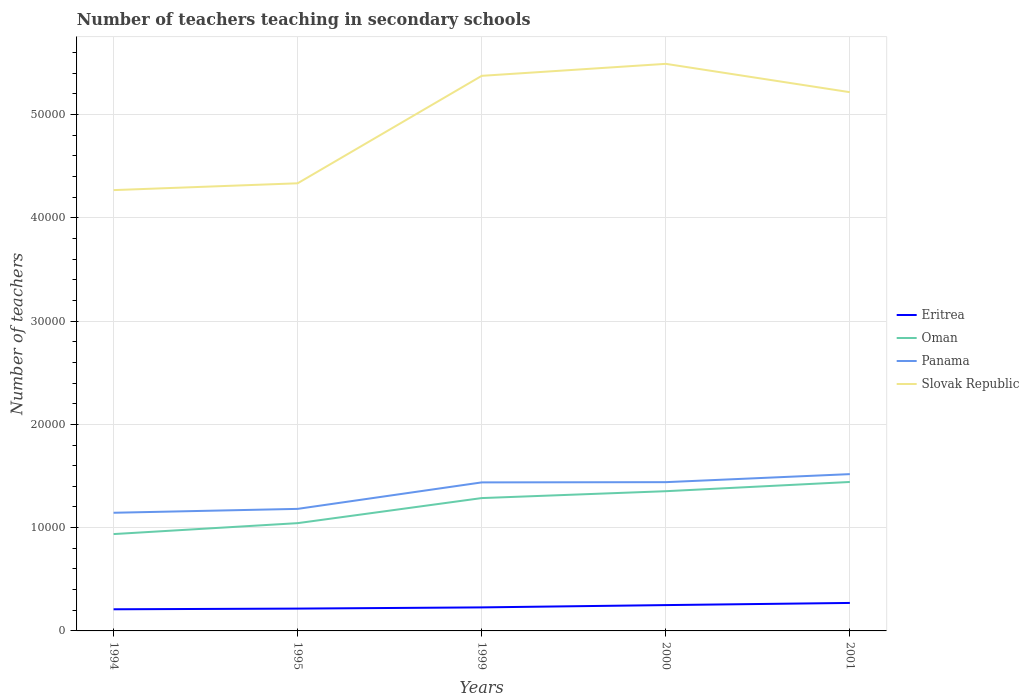Does the line corresponding to Eritrea intersect with the line corresponding to Panama?
Make the answer very short. No. Is the number of lines equal to the number of legend labels?
Offer a terse response. Yes. Across all years, what is the maximum number of teachers teaching in secondary schools in Slovak Republic?
Your answer should be very brief. 4.27e+04. In which year was the number of teachers teaching in secondary schools in Eritrea maximum?
Provide a short and direct response. 1994. What is the total number of teachers teaching in secondary schools in Slovak Republic in the graph?
Give a very brief answer. -660. What is the difference between the highest and the second highest number of teachers teaching in secondary schools in Oman?
Offer a terse response. 5046. What is the difference between the highest and the lowest number of teachers teaching in secondary schools in Eritrea?
Offer a very short reply. 2. Are the values on the major ticks of Y-axis written in scientific E-notation?
Ensure brevity in your answer.  No. Does the graph contain any zero values?
Provide a succinct answer. No. What is the title of the graph?
Your answer should be compact. Number of teachers teaching in secondary schools. What is the label or title of the Y-axis?
Keep it short and to the point. Number of teachers. What is the Number of teachers in Eritrea in 1994?
Make the answer very short. 2095. What is the Number of teachers of Oman in 1994?
Give a very brief answer. 9376. What is the Number of teachers of Panama in 1994?
Make the answer very short. 1.14e+04. What is the Number of teachers of Slovak Republic in 1994?
Provide a short and direct response. 4.27e+04. What is the Number of teachers of Eritrea in 1995?
Your response must be concise. 2162. What is the Number of teachers in Oman in 1995?
Your response must be concise. 1.04e+04. What is the Number of teachers in Panama in 1995?
Your answer should be very brief. 1.18e+04. What is the Number of teachers in Slovak Republic in 1995?
Keep it short and to the point. 4.33e+04. What is the Number of teachers in Eritrea in 1999?
Keep it short and to the point. 2278. What is the Number of teachers of Oman in 1999?
Your answer should be very brief. 1.29e+04. What is the Number of teachers of Panama in 1999?
Your response must be concise. 1.44e+04. What is the Number of teachers of Slovak Republic in 1999?
Your answer should be compact. 5.37e+04. What is the Number of teachers in Eritrea in 2000?
Your response must be concise. 2501. What is the Number of teachers of Oman in 2000?
Give a very brief answer. 1.35e+04. What is the Number of teachers of Panama in 2000?
Offer a terse response. 1.44e+04. What is the Number of teachers of Slovak Republic in 2000?
Keep it short and to the point. 5.49e+04. What is the Number of teachers in Eritrea in 2001?
Your answer should be very brief. 2710. What is the Number of teachers in Oman in 2001?
Your response must be concise. 1.44e+04. What is the Number of teachers in Panama in 2001?
Provide a succinct answer. 1.52e+04. What is the Number of teachers of Slovak Republic in 2001?
Your answer should be compact. 5.22e+04. Across all years, what is the maximum Number of teachers in Eritrea?
Your response must be concise. 2710. Across all years, what is the maximum Number of teachers in Oman?
Your response must be concise. 1.44e+04. Across all years, what is the maximum Number of teachers in Panama?
Provide a short and direct response. 1.52e+04. Across all years, what is the maximum Number of teachers of Slovak Republic?
Your answer should be compact. 5.49e+04. Across all years, what is the minimum Number of teachers in Eritrea?
Your response must be concise. 2095. Across all years, what is the minimum Number of teachers of Oman?
Your answer should be compact. 9376. Across all years, what is the minimum Number of teachers in Panama?
Keep it short and to the point. 1.14e+04. Across all years, what is the minimum Number of teachers of Slovak Republic?
Your answer should be compact. 4.27e+04. What is the total Number of teachers in Eritrea in the graph?
Your answer should be very brief. 1.17e+04. What is the total Number of teachers of Oman in the graph?
Keep it short and to the point. 6.06e+04. What is the total Number of teachers of Panama in the graph?
Offer a terse response. 6.72e+04. What is the total Number of teachers of Slovak Republic in the graph?
Make the answer very short. 2.47e+05. What is the difference between the Number of teachers of Eritrea in 1994 and that in 1995?
Make the answer very short. -67. What is the difference between the Number of teachers of Oman in 1994 and that in 1995?
Provide a succinct answer. -1059. What is the difference between the Number of teachers of Panama in 1994 and that in 1995?
Your answer should be compact. -377. What is the difference between the Number of teachers in Slovak Republic in 1994 and that in 1995?
Provide a succinct answer. -660. What is the difference between the Number of teachers of Eritrea in 1994 and that in 1999?
Keep it short and to the point. -183. What is the difference between the Number of teachers in Oman in 1994 and that in 1999?
Your response must be concise. -3486. What is the difference between the Number of teachers of Panama in 1994 and that in 1999?
Your answer should be compact. -2940. What is the difference between the Number of teachers in Slovak Republic in 1994 and that in 1999?
Make the answer very short. -1.11e+04. What is the difference between the Number of teachers in Eritrea in 1994 and that in 2000?
Provide a short and direct response. -406. What is the difference between the Number of teachers in Oman in 1994 and that in 2000?
Your response must be concise. -4152. What is the difference between the Number of teachers of Panama in 1994 and that in 2000?
Provide a succinct answer. -2964. What is the difference between the Number of teachers in Slovak Republic in 1994 and that in 2000?
Provide a succinct answer. -1.22e+04. What is the difference between the Number of teachers of Eritrea in 1994 and that in 2001?
Provide a short and direct response. -615. What is the difference between the Number of teachers in Oman in 1994 and that in 2001?
Provide a short and direct response. -5046. What is the difference between the Number of teachers in Panama in 1994 and that in 2001?
Provide a short and direct response. -3741. What is the difference between the Number of teachers in Slovak Republic in 1994 and that in 2001?
Provide a succinct answer. -9480. What is the difference between the Number of teachers in Eritrea in 1995 and that in 1999?
Make the answer very short. -116. What is the difference between the Number of teachers of Oman in 1995 and that in 1999?
Your response must be concise. -2427. What is the difference between the Number of teachers of Panama in 1995 and that in 1999?
Your answer should be compact. -2563. What is the difference between the Number of teachers in Slovak Republic in 1995 and that in 1999?
Provide a succinct answer. -1.04e+04. What is the difference between the Number of teachers of Eritrea in 1995 and that in 2000?
Make the answer very short. -339. What is the difference between the Number of teachers of Oman in 1995 and that in 2000?
Offer a very short reply. -3093. What is the difference between the Number of teachers of Panama in 1995 and that in 2000?
Your response must be concise. -2587. What is the difference between the Number of teachers in Slovak Republic in 1995 and that in 2000?
Ensure brevity in your answer.  -1.16e+04. What is the difference between the Number of teachers of Eritrea in 1995 and that in 2001?
Your answer should be compact. -548. What is the difference between the Number of teachers in Oman in 1995 and that in 2001?
Your answer should be compact. -3987. What is the difference between the Number of teachers of Panama in 1995 and that in 2001?
Offer a very short reply. -3364. What is the difference between the Number of teachers of Slovak Republic in 1995 and that in 2001?
Your answer should be compact. -8820. What is the difference between the Number of teachers of Eritrea in 1999 and that in 2000?
Ensure brevity in your answer.  -223. What is the difference between the Number of teachers of Oman in 1999 and that in 2000?
Make the answer very short. -666. What is the difference between the Number of teachers of Panama in 1999 and that in 2000?
Your answer should be very brief. -24. What is the difference between the Number of teachers in Slovak Republic in 1999 and that in 2000?
Offer a very short reply. -1160. What is the difference between the Number of teachers in Eritrea in 1999 and that in 2001?
Your answer should be very brief. -432. What is the difference between the Number of teachers in Oman in 1999 and that in 2001?
Give a very brief answer. -1560. What is the difference between the Number of teachers of Panama in 1999 and that in 2001?
Your answer should be compact. -801. What is the difference between the Number of teachers of Slovak Republic in 1999 and that in 2001?
Keep it short and to the point. 1585. What is the difference between the Number of teachers in Eritrea in 2000 and that in 2001?
Make the answer very short. -209. What is the difference between the Number of teachers in Oman in 2000 and that in 2001?
Make the answer very short. -894. What is the difference between the Number of teachers of Panama in 2000 and that in 2001?
Your answer should be compact. -777. What is the difference between the Number of teachers of Slovak Republic in 2000 and that in 2001?
Your answer should be very brief. 2745. What is the difference between the Number of teachers of Eritrea in 1994 and the Number of teachers of Oman in 1995?
Give a very brief answer. -8340. What is the difference between the Number of teachers of Eritrea in 1994 and the Number of teachers of Panama in 1995?
Ensure brevity in your answer.  -9722. What is the difference between the Number of teachers in Eritrea in 1994 and the Number of teachers in Slovak Republic in 1995?
Your answer should be compact. -4.12e+04. What is the difference between the Number of teachers in Oman in 1994 and the Number of teachers in Panama in 1995?
Your response must be concise. -2441. What is the difference between the Number of teachers in Oman in 1994 and the Number of teachers in Slovak Republic in 1995?
Give a very brief answer. -3.40e+04. What is the difference between the Number of teachers in Panama in 1994 and the Number of teachers in Slovak Republic in 1995?
Offer a terse response. -3.19e+04. What is the difference between the Number of teachers in Eritrea in 1994 and the Number of teachers in Oman in 1999?
Provide a short and direct response. -1.08e+04. What is the difference between the Number of teachers in Eritrea in 1994 and the Number of teachers in Panama in 1999?
Your answer should be compact. -1.23e+04. What is the difference between the Number of teachers in Eritrea in 1994 and the Number of teachers in Slovak Republic in 1999?
Ensure brevity in your answer.  -5.16e+04. What is the difference between the Number of teachers of Oman in 1994 and the Number of teachers of Panama in 1999?
Provide a short and direct response. -5004. What is the difference between the Number of teachers in Oman in 1994 and the Number of teachers in Slovak Republic in 1999?
Offer a very short reply. -4.44e+04. What is the difference between the Number of teachers in Panama in 1994 and the Number of teachers in Slovak Republic in 1999?
Make the answer very short. -4.23e+04. What is the difference between the Number of teachers in Eritrea in 1994 and the Number of teachers in Oman in 2000?
Provide a short and direct response. -1.14e+04. What is the difference between the Number of teachers of Eritrea in 1994 and the Number of teachers of Panama in 2000?
Offer a very short reply. -1.23e+04. What is the difference between the Number of teachers of Eritrea in 1994 and the Number of teachers of Slovak Republic in 2000?
Keep it short and to the point. -5.28e+04. What is the difference between the Number of teachers of Oman in 1994 and the Number of teachers of Panama in 2000?
Provide a short and direct response. -5028. What is the difference between the Number of teachers in Oman in 1994 and the Number of teachers in Slovak Republic in 2000?
Offer a very short reply. -4.55e+04. What is the difference between the Number of teachers of Panama in 1994 and the Number of teachers of Slovak Republic in 2000?
Ensure brevity in your answer.  -4.35e+04. What is the difference between the Number of teachers of Eritrea in 1994 and the Number of teachers of Oman in 2001?
Provide a short and direct response. -1.23e+04. What is the difference between the Number of teachers of Eritrea in 1994 and the Number of teachers of Panama in 2001?
Ensure brevity in your answer.  -1.31e+04. What is the difference between the Number of teachers of Eritrea in 1994 and the Number of teachers of Slovak Republic in 2001?
Make the answer very short. -5.01e+04. What is the difference between the Number of teachers of Oman in 1994 and the Number of teachers of Panama in 2001?
Your response must be concise. -5805. What is the difference between the Number of teachers in Oman in 1994 and the Number of teachers in Slovak Republic in 2001?
Provide a succinct answer. -4.28e+04. What is the difference between the Number of teachers in Panama in 1994 and the Number of teachers in Slovak Republic in 2001?
Make the answer very short. -4.07e+04. What is the difference between the Number of teachers of Eritrea in 1995 and the Number of teachers of Oman in 1999?
Provide a short and direct response. -1.07e+04. What is the difference between the Number of teachers in Eritrea in 1995 and the Number of teachers in Panama in 1999?
Offer a terse response. -1.22e+04. What is the difference between the Number of teachers of Eritrea in 1995 and the Number of teachers of Slovak Republic in 1999?
Make the answer very short. -5.16e+04. What is the difference between the Number of teachers of Oman in 1995 and the Number of teachers of Panama in 1999?
Keep it short and to the point. -3945. What is the difference between the Number of teachers in Oman in 1995 and the Number of teachers in Slovak Republic in 1999?
Provide a short and direct response. -4.33e+04. What is the difference between the Number of teachers of Panama in 1995 and the Number of teachers of Slovak Republic in 1999?
Your answer should be compact. -4.19e+04. What is the difference between the Number of teachers in Eritrea in 1995 and the Number of teachers in Oman in 2000?
Offer a terse response. -1.14e+04. What is the difference between the Number of teachers in Eritrea in 1995 and the Number of teachers in Panama in 2000?
Ensure brevity in your answer.  -1.22e+04. What is the difference between the Number of teachers in Eritrea in 1995 and the Number of teachers in Slovak Republic in 2000?
Offer a very short reply. -5.27e+04. What is the difference between the Number of teachers in Oman in 1995 and the Number of teachers in Panama in 2000?
Offer a very short reply. -3969. What is the difference between the Number of teachers of Oman in 1995 and the Number of teachers of Slovak Republic in 2000?
Offer a terse response. -4.45e+04. What is the difference between the Number of teachers of Panama in 1995 and the Number of teachers of Slovak Republic in 2000?
Your response must be concise. -4.31e+04. What is the difference between the Number of teachers of Eritrea in 1995 and the Number of teachers of Oman in 2001?
Provide a short and direct response. -1.23e+04. What is the difference between the Number of teachers in Eritrea in 1995 and the Number of teachers in Panama in 2001?
Offer a very short reply. -1.30e+04. What is the difference between the Number of teachers in Eritrea in 1995 and the Number of teachers in Slovak Republic in 2001?
Offer a very short reply. -5.00e+04. What is the difference between the Number of teachers of Oman in 1995 and the Number of teachers of Panama in 2001?
Offer a terse response. -4746. What is the difference between the Number of teachers of Oman in 1995 and the Number of teachers of Slovak Republic in 2001?
Your answer should be very brief. -4.17e+04. What is the difference between the Number of teachers of Panama in 1995 and the Number of teachers of Slovak Republic in 2001?
Your response must be concise. -4.03e+04. What is the difference between the Number of teachers in Eritrea in 1999 and the Number of teachers in Oman in 2000?
Your response must be concise. -1.12e+04. What is the difference between the Number of teachers of Eritrea in 1999 and the Number of teachers of Panama in 2000?
Offer a terse response. -1.21e+04. What is the difference between the Number of teachers of Eritrea in 1999 and the Number of teachers of Slovak Republic in 2000?
Offer a terse response. -5.26e+04. What is the difference between the Number of teachers in Oman in 1999 and the Number of teachers in Panama in 2000?
Offer a terse response. -1542. What is the difference between the Number of teachers in Oman in 1999 and the Number of teachers in Slovak Republic in 2000?
Keep it short and to the point. -4.20e+04. What is the difference between the Number of teachers in Panama in 1999 and the Number of teachers in Slovak Republic in 2000?
Offer a terse response. -4.05e+04. What is the difference between the Number of teachers in Eritrea in 1999 and the Number of teachers in Oman in 2001?
Provide a short and direct response. -1.21e+04. What is the difference between the Number of teachers in Eritrea in 1999 and the Number of teachers in Panama in 2001?
Give a very brief answer. -1.29e+04. What is the difference between the Number of teachers of Eritrea in 1999 and the Number of teachers of Slovak Republic in 2001?
Your answer should be compact. -4.99e+04. What is the difference between the Number of teachers of Oman in 1999 and the Number of teachers of Panama in 2001?
Your answer should be very brief. -2319. What is the difference between the Number of teachers in Oman in 1999 and the Number of teachers in Slovak Republic in 2001?
Ensure brevity in your answer.  -3.93e+04. What is the difference between the Number of teachers of Panama in 1999 and the Number of teachers of Slovak Republic in 2001?
Offer a very short reply. -3.78e+04. What is the difference between the Number of teachers in Eritrea in 2000 and the Number of teachers in Oman in 2001?
Your answer should be very brief. -1.19e+04. What is the difference between the Number of teachers in Eritrea in 2000 and the Number of teachers in Panama in 2001?
Offer a very short reply. -1.27e+04. What is the difference between the Number of teachers of Eritrea in 2000 and the Number of teachers of Slovak Republic in 2001?
Give a very brief answer. -4.97e+04. What is the difference between the Number of teachers of Oman in 2000 and the Number of teachers of Panama in 2001?
Provide a short and direct response. -1653. What is the difference between the Number of teachers in Oman in 2000 and the Number of teachers in Slovak Republic in 2001?
Keep it short and to the point. -3.86e+04. What is the difference between the Number of teachers in Panama in 2000 and the Number of teachers in Slovak Republic in 2001?
Your answer should be very brief. -3.78e+04. What is the average Number of teachers of Eritrea per year?
Your answer should be very brief. 2349.2. What is the average Number of teachers of Oman per year?
Keep it short and to the point. 1.21e+04. What is the average Number of teachers of Panama per year?
Provide a short and direct response. 1.34e+04. What is the average Number of teachers of Slovak Republic per year?
Offer a terse response. 4.94e+04. In the year 1994, what is the difference between the Number of teachers of Eritrea and Number of teachers of Oman?
Offer a terse response. -7281. In the year 1994, what is the difference between the Number of teachers in Eritrea and Number of teachers in Panama?
Ensure brevity in your answer.  -9345. In the year 1994, what is the difference between the Number of teachers in Eritrea and Number of teachers in Slovak Republic?
Your answer should be very brief. -4.06e+04. In the year 1994, what is the difference between the Number of teachers in Oman and Number of teachers in Panama?
Offer a very short reply. -2064. In the year 1994, what is the difference between the Number of teachers of Oman and Number of teachers of Slovak Republic?
Provide a succinct answer. -3.33e+04. In the year 1994, what is the difference between the Number of teachers in Panama and Number of teachers in Slovak Republic?
Your answer should be compact. -3.12e+04. In the year 1995, what is the difference between the Number of teachers in Eritrea and Number of teachers in Oman?
Offer a very short reply. -8273. In the year 1995, what is the difference between the Number of teachers of Eritrea and Number of teachers of Panama?
Make the answer very short. -9655. In the year 1995, what is the difference between the Number of teachers of Eritrea and Number of teachers of Slovak Republic?
Ensure brevity in your answer.  -4.12e+04. In the year 1995, what is the difference between the Number of teachers in Oman and Number of teachers in Panama?
Your answer should be compact. -1382. In the year 1995, what is the difference between the Number of teachers of Oman and Number of teachers of Slovak Republic?
Offer a very short reply. -3.29e+04. In the year 1995, what is the difference between the Number of teachers in Panama and Number of teachers in Slovak Republic?
Provide a succinct answer. -3.15e+04. In the year 1999, what is the difference between the Number of teachers in Eritrea and Number of teachers in Oman?
Keep it short and to the point. -1.06e+04. In the year 1999, what is the difference between the Number of teachers in Eritrea and Number of teachers in Panama?
Offer a terse response. -1.21e+04. In the year 1999, what is the difference between the Number of teachers of Eritrea and Number of teachers of Slovak Republic?
Your answer should be compact. -5.15e+04. In the year 1999, what is the difference between the Number of teachers of Oman and Number of teachers of Panama?
Make the answer very short. -1518. In the year 1999, what is the difference between the Number of teachers of Oman and Number of teachers of Slovak Republic?
Your answer should be compact. -4.09e+04. In the year 1999, what is the difference between the Number of teachers of Panama and Number of teachers of Slovak Republic?
Offer a terse response. -3.94e+04. In the year 2000, what is the difference between the Number of teachers of Eritrea and Number of teachers of Oman?
Provide a short and direct response. -1.10e+04. In the year 2000, what is the difference between the Number of teachers in Eritrea and Number of teachers in Panama?
Ensure brevity in your answer.  -1.19e+04. In the year 2000, what is the difference between the Number of teachers of Eritrea and Number of teachers of Slovak Republic?
Your response must be concise. -5.24e+04. In the year 2000, what is the difference between the Number of teachers of Oman and Number of teachers of Panama?
Provide a short and direct response. -876. In the year 2000, what is the difference between the Number of teachers of Oman and Number of teachers of Slovak Republic?
Ensure brevity in your answer.  -4.14e+04. In the year 2000, what is the difference between the Number of teachers of Panama and Number of teachers of Slovak Republic?
Offer a very short reply. -4.05e+04. In the year 2001, what is the difference between the Number of teachers in Eritrea and Number of teachers in Oman?
Offer a very short reply. -1.17e+04. In the year 2001, what is the difference between the Number of teachers in Eritrea and Number of teachers in Panama?
Offer a very short reply. -1.25e+04. In the year 2001, what is the difference between the Number of teachers of Eritrea and Number of teachers of Slovak Republic?
Ensure brevity in your answer.  -4.94e+04. In the year 2001, what is the difference between the Number of teachers in Oman and Number of teachers in Panama?
Offer a terse response. -759. In the year 2001, what is the difference between the Number of teachers of Oman and Number of teachers of Slovak Republic?
Your answer should be compact. -3.77e+04. In the year 2001, what is the difference between the Number of teachers in Panama and Number of teachers in Slovak Republic?
Keep it short and to the point. -3.70e+04. What is the ratio of the Number of teachers of Oman in 1994 to that in 1995?
Give a very brief answer. 0.9. What is the ratio of the Number of teachers in Panama in 1994 to that in 1995?
Provide a short and direct response. 0.97. What is the ratio of the Number of teachers in Eritrea in 1994 to that in 1999?
Provide a succinct answer. 0.92. What is the ratio of the Number of teachers of Oman in 1994 to that in 1999?
Ensure brevity in your answer.  0.73. What is the ratio of the Number of teachers of Panama in 1994 to that in 1999?
Your response must be concise. 0.8. What is the ratio of the Number of teachers in Slovak Republic in 1994 to that in 1999?
Offer a terse response. 0.79. What is the ratio of the Number of teachers of Eritrea in 1994 to that in 2000?
Ensure brevity in your answer.  0.84. What is the ratio of the Number of teachers of Oman in 1994 to that in 2000?
Provide a short and direct response. 0.69. What is the ratio of the Number of teachers of Panama in 1994 to that in 2000?
Your answer should be very brief. 0.79. What is the ratio of the Number of teachers in Slovak Republic in 1994 to that in 2000?
Offer a very short reply. 0.78. What is the ratio of the Number of teachers of Eritrea in 1994 to that in 2001?
Your answer should be compact. 0.77. What is the ratio of the Number of teachers of Oman in 1994 to that in 2001?
Offer a very short reply. 0.65. What is the ratio of the Number of teachers of Panama in 1994 to that in 2001?
Your answer should be compact. 0.75. What is the ratio of the Number of teachers of Slovak Republic in 1994 to that in 2001?
Your answer should be compact. 0.82. What is the ratio of the Number of teachers of Eritrea in 1995 to that in 1999?
Keep it short and to the point. 0.95. What is the ratio of the Number of teachers in Oman in 1995 to that in 1999?
Offer a terse response. 0.81. What is the ratio of the Number of teachers in Panama in 1995 to that in 1999?
Keep it short and to the point. 0.82. What is the ratio of the Number of teachers of Slovak Republic in 1995 to that in 1999?
Offer a terse response. 0.81. What is the ratio of the Number of teachers of Eritrea in 1995 to that in 2000?
Provide a short and direct response. 0.86. What is the ratio of the Number of teachers of Oman in 1995 to that in 2000?
Provide a succinct answer. 0.77. What is the ratio of the Number of teachers of Panama in 1995 to that in 2000?
Ensure brevity in your answer.  0.82. What is the ratio of the Number of teachers in Slovak Republic in 1995 to that in 2000?
Give a very brief answer. 0.79. What is the ratio of the Number of teachers of Eritrea in 1995 to that in 2001?
Your answer should be very brief. 0.8. What is the ratio of the Number of teachers of Oman in 1995 to that in 2001?
Ensure brevity in your answer.  0.72. What is the ratio of the Number of teachers of Panama in 1995 to that in 2001?
Your response must be concise. 0.78. What is the ratio of the Number of teachers in Slovak Republic in 1995 to that in 2001?
Offer a terse response. 0.83. What is the ratio of the Number of teachers of Eritrea in 1999 to that in 2000?
Keep it short and to the point. 0.91. What is the ratio of the Number of teachers in Oman in 1999 to that in 2000?
Offer a terse response. 0.95. What is the ratio of the Number of teachers in Panama in 1999 to that in 2000?
Offer a terse response. 1. What is the ratio of the Number of teachers in Slovak Republic in 1999 to that in 2000?
Offer a very short reply. 0.98. What is the ratio of the Number of teachers in Eritrea in 1999 to that in 2001?
Your answer should be compact. 0.84. What is the ratio of the Number of teachers of Oman in 1999 to that in 2001?
Give a very brief answer. 0.89. What is the ratio of the Number of teachers of Panama in 1999 to that in 2001?
Keep it short and to the point. 0.95. What is the ratio of the Number of teachers of Slovak Republic in 1999 to that in 2001?
Keep it short and to the point. 1.03. What is the ratio of the Number of teachers of Eritrea in 2000 to that in 2001?
Keep it short and to the point. 0.92. What is the ratio of the Number of teachers of Oman in 2000 to that in 2001?
Your answer should be compact. 0.94. What is the ratio of the Number of teachers of Panama in 2000 to that in 2001?
Provide a short and direct response. 0.95. What is the ratio of the Number of teachers of Slovak Republic in 2000 to that in 2001?
Offer a very short reply. 1.05. What is the difference between the highest and the second highest Number of teachers of Eritrea?
Offer a very short reply. 209. What is the difference between the highest and the second highest Number of teachers in Oman?
Make the answer very short. 894. What is the difference between the highest and the second highest Number of teachers in Panama?
Ensure brevity in your answer.  777. What is the difference between the highest and the second highest Number of teachers in Slovak Republic?
Your answer should be compact. 1160. What is the difference between the highest and the lowest Number of teachers of Eritrea?
Your answer should be very brief. 615. What is the difference between the highest and the lowest Number of teachers of Oman?
Make the answer very short. 5046. What is the difference between the highest and the lowest Number of teachers in Panama?
Offer a terse response. 3741. What is the difference between the highest and the lowest Number of teachers of Slovak Republic?
Give a very brief answer. 1.22e+04. 